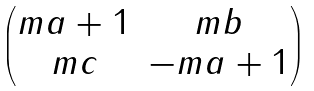Convert formula to latex. <formula><loc_0><loc_0><loc_500><loc_500>\begin{pmatrix} m a + 1 & m b \\ m c & - m a + 1 \end{pmatrix}</formula> 